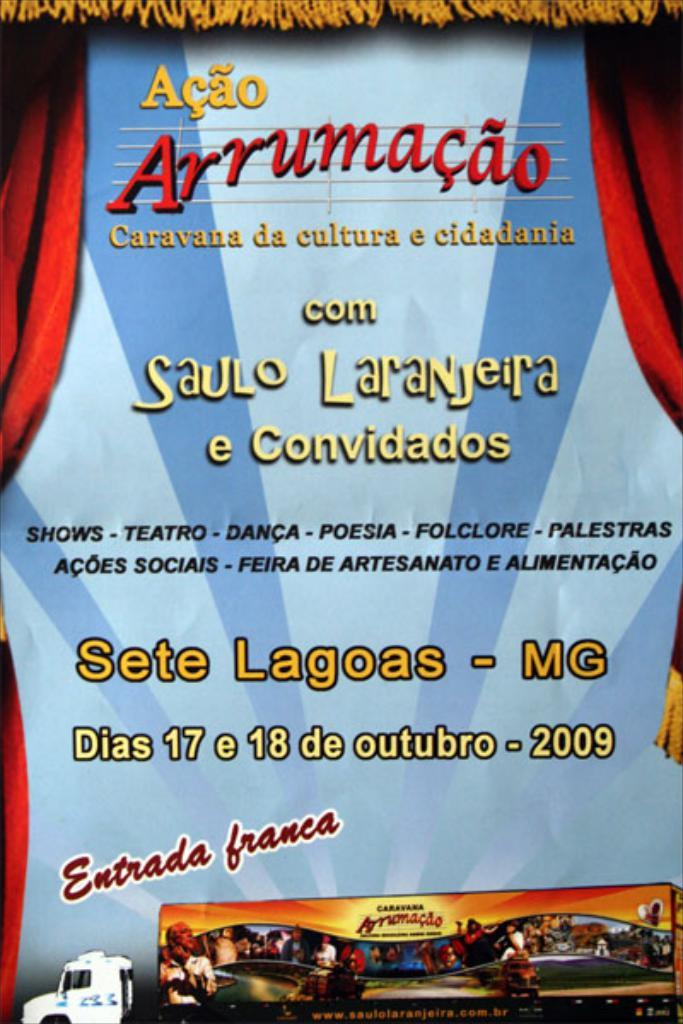Provide a one-sentence caption for the provided image. A poster that says Acao Arrumacao comSaulo Laranjeira on it. 